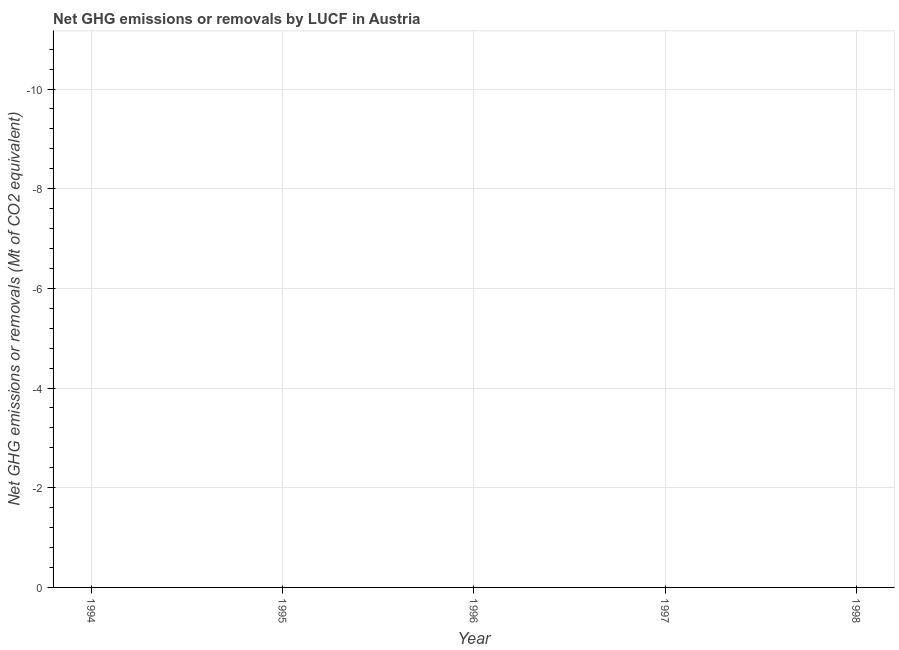In how many years, is the ghg net emissions or removals greater than -2.4 Mt?
Ensure brevity in your answer.  0. How many years are there in the graph?
Your response must be concise. 5. Are the values on the major ticks of Y-axis written in scientific E-notation?
Your answer should be very brief. No. What is the title of the graph?
Keep it short and to the point. Net GHG emissions or removals by LUCF in Austria. What is the label or title of the Y-axis?
Give a very brief answer. Net GHG emissions or removals (Mt of CO2 equivalent). What is the Net GHG emissions or removals (Mt of CO2 equivalent) of 1994?
Make the answer very short. 0. What is the Net GHG emissions or removals (Mt of CO2 equivalent) in 1995?
Your answer should be compact. 0. What is the Net GHG emissions or removals (Mt of CO2 equivalent) in 1996?
Keep it short and to the point. 0. 